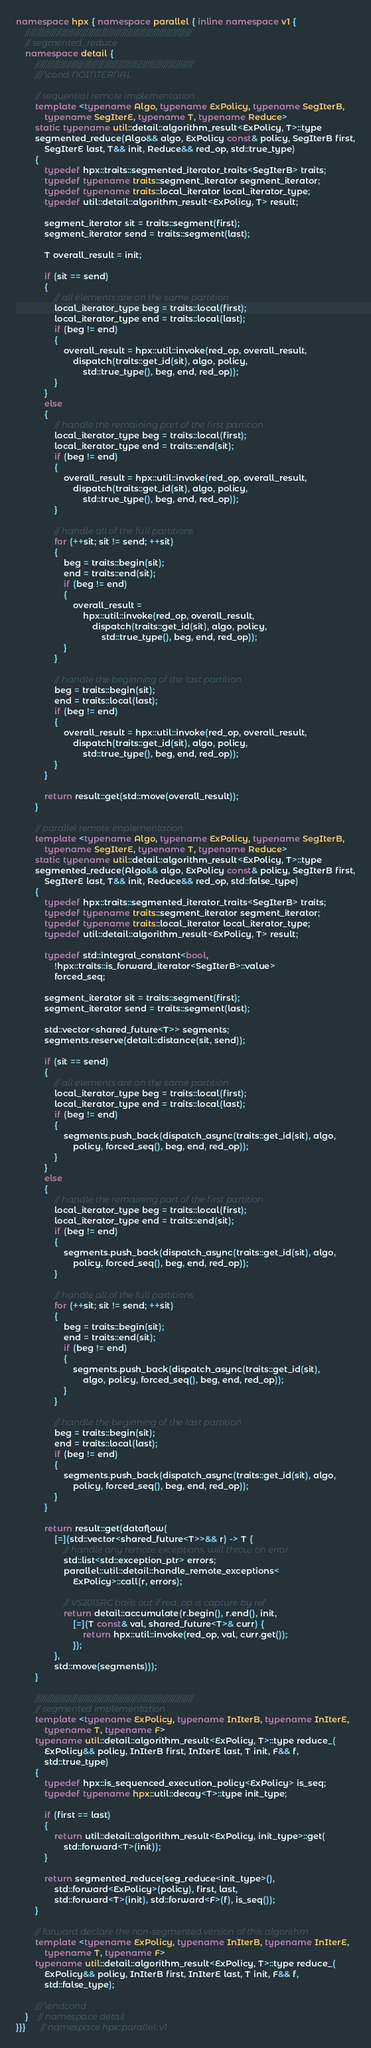<code> <loc_0><loc_0><loc_500><loc_500><_C++_>
namespace hpx { namespace parallel { inline namespace v1 {
    ///////////////////////////////////////////////////////////////////////////
    // segmented_reduce
    namespace detail {
        ///////////////////////////////////////////////////////////////////////
        /// \cond NOINTERNAL

        // sequential remote implementation
        template <typename Algo, typename ExPolicy, typename SegIterB,
            typename SegIterE, typename T, typename Reduce>
        static typename util::detail::algorithm_result<ExPolicy, T>::type
        segmented_reduce(Algo&& algo, ExPolicy const& policy, SegIterB first,
            SegIterE last, T&& init, Reduce&& red_op, std::true_type)
        {
            typedef hpx::traits::segmented_iterator_traits<SegIterB> traits;
            typedef typename traits::segment_iterator segment_iterator;
            typedef typename traits::local_iterator local_iterator_type;
            typedef util::detail::algorithm_result<ExPolicy, T> result;

            segment_iterator sit = traits::segment(first);
            segment_iterator send = traits::segment(last);

            T overall_result = init;

            if (sit == send)
            {
                // all elements are on the same partition
                local_iterator_type beg = traits::local(first);
                local_iterator_type end = traits::local(last);
                if (beg != end)
                {
                    overall_result = hpx::util::invoke(red_op, overall_result,
                        dispatch(traits::get_id(sit), algo, policy,
                            std::true_type(), beg, end, red_op));
                }
            }
            else
            {
                // handle the remaining part of the first partition
                local_iterator_type beg = traits::local(first);
                local_iterator_type end = traits::end(sit);
                if (beg != end)
                {
                    overall_result = hpx::util::invoke(red_op, overall_result,
                        dispatch(traits::get_id(sit), algo, policy,
                            std::true_type(), beg, end, red_op));
                }

                // handle all of the full partitions
                for (++sit; sit != send; ++sit)
                {
                    beg = traits::begin(sit);
                    end = traits::end(sit);
                    if (beg != end)
                    {
                        overall_result =
                            hpx::util::invoke(red_op, overall_result,
                                dispatch(traits::get_id(sit), algo, policy,
                                    std::true_type(), beg, end, red_op));
                    }
                }

                // handle the beginning of the last partition
                beg = traits::begin(sit);
                end = traits::local(last);
                if (beg != end)
                {
                    overall_result = hpx::util::invoke(red_op, overall_result,
                        dispatch(traits::get_id(sit), algo, policy,
                            std::true_type(), beg, end, red_op));
                }
            }

            return result::get(std::move(overall_result));
        }

        // parallel remote implementation
        template <typename Algo, typename ExPolicy, typename SegIterB,
            typename SegIterE, typename T, typename Reduce>
        static typename util::detail::algorithm_result<ExPolicy, T>::type
        segmented_reduce(Algo&& algo, ExPolicy const& policy, SegIterB first,
            SegIterE last, T&& init, Reduce&& red_op, std::false_type)
        {
            typedef hpx::traits::segmented_iterator_traits<SegIterB> traits;
            typedef typename traits::segment_iterator segment_iterator;
            typedef typename traits::local_iterator local_iterator_type;
            typedef util::detail::algorithm_result<ExPolicy, T> result;

            typedef std::integral_constant<bool,
                !hpx::traits::is_forward_iterator<SegIterB>::value>
                forced_seq;

            segment_iterator sit = traits::segment(first);
            segment_iterator send = traits::segment(last);

            std::vector<shared_future<T>> segments;
            segments.reserve(detail::distance(sit, send));

            if (sit == send)
            {
                // all elements are on the same partition
                local_iterator_type beg = traits::local(first);
                local_iterator_type end = traits::local(last);
                if (beg != end)
                {
                    segments.push_back(dispatch_async(traits::get_id(sit), algo,
                        policy, forced_seq(), beg, end, red_op));
                }
            }
            else
            {
                // handle the remaining part of the first partition
                local_iterator_type beg = traits::local(first);
                local_iterator_type end = traits::end(sit);
                if (beg != end)
                {
                    segments.push_back(dispatch_async(traits::get_id(sit), algo,
                        policy, forced_seq(), beg, end, red_op));
                }

                // handle all of the full partitions
                for (++sit; sit != send; ++sit)
                {
                    beg = traits::begin(sit);
                    end = traits::end(sit);
                    if (beg != end)
                    {
                        segments.push_back(dispatch_async(traits::get_id(sit),
                            algo, policy, forced_seq(), beg, end, red_op));
                    }
                }

                // handle the beginning of the last partition
                beg = traits::begin(sit);
                end = traits::local(last);
                if (beg != end)
                {
                    segments.push_back(dispatch_async(traits::get_id(sit), algo,
                        policy, forced_seq(), beg, end, red_op));
                }
            }

            return result::get(dataflow(
                [=](std::vector<shared_future<T>>&& r) -> T {
                    // handle any remote exceptions, will throw on error
                    std::list<std::exception_ptr> errors;
                    parallel::util::detail::handle_remote_exceptions<
                        ExPolicy>::call(r, errors);

                    // VS2015RC bails out if red_op is capture by ref
                    return detail::accumulate(r.begin(), r.end(), init,
                        [=](T const& val, shared_future<T>& curr) {
                            return hpx::util::invoke(red_op, val, curr.get());
                        });
                },
                std::move(segments)));
        }

        ///////////////////////////////////////////////////////////////////////
        // segmented implementation
        template <typename ExPolicy, typename InIterB, typename InIterE,
            typename T, typename F>
        typename util::detail::algorithm_result<ExPolicy, T>::type reduce_(
            ExPolicy&& policy, InIterB first, InIterE last, T init, F&& f,
            std::true_type)
        {
            typedef hpx::is_sequenced_execution_policy<ExPolicy> is_seq;
            typedef typename hpx::util::decay<T>::type init_type;

            if (first == last)
            {
                return util::detail::algorithm_result<ExPolicy, init_type>::get(
                    std::forward<T>(init));
            }

            return segmented_reduce(seg_reduce<init_type>(),
                std::forward<ExPolicy>(policy), first, last,
                std::forward<T>(init), std::forward<F>(f), is_seq());
        }

        // forward declare the non-segmented version of this algorithm
        template <typename ExPolicy, typename InIterB, typename InIterE,
            typename T, typename F>
        typename util::detail::algorithm_result<ExPolicy, T>::type reduce_(
            ExPolicy&& policy, InIterB first, InIterE last, T init, F&& f,
            std::false_type);

        /// \endcond
    }    // namespace detail
}}}      // namespace hpx::parallel::v1
</code> 